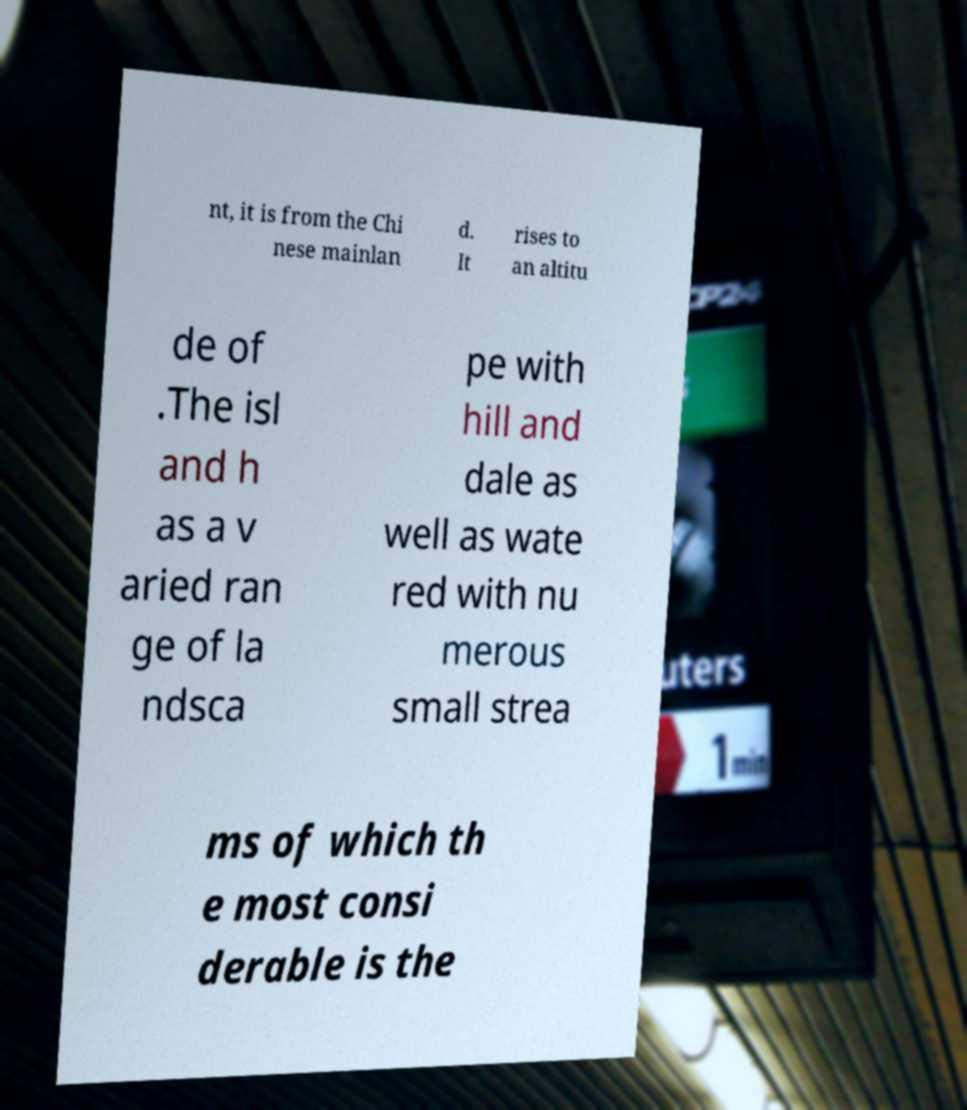Could you extract and type out the text from this image? nt, it is from the Chi nese mainlan d. It rises to an altitu de of .The isl and h as a v aried ran ge of la ndsca pe with hill and dale as well as wate red with nu merous small strea ms of which th e most consi derable is the 